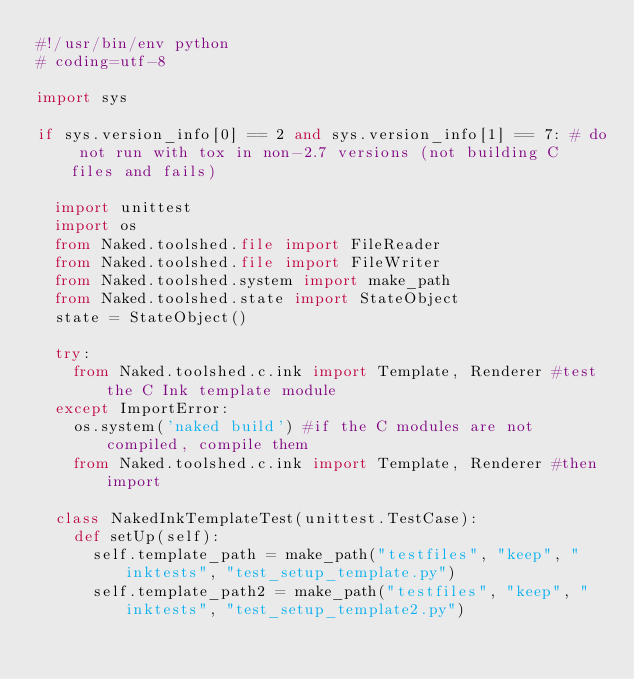<code> <loc_0><loc_0><loc_500><loc_500><_Python_>#!/usr/bin/env python
# coding=utf-8

import sys

if sys.version_info[0] == 2 and sys.version_info[1] == 7: # do not run with tox in non-2.7 versions (not building C files and fails)

	import unittest
	import os
	from Naked.toolshed.file import FileReader
	from Naked.toolshed.file import FileWriter
	from Naked.toolshed.system import make_path
	from Naked.toolshed.state import StateObject
	state = StateObject()

	try:
		from Naked.toolshed.c.ink import Template, Renderer #test the C Ink template module
	except ImportError:
		os.system('naked build') #if the C modules are not compiled, compile them
		from Naked.toolshed.c.ink import Template, Renderer #then import

	class NakedInkTemplateTest(unittest.TestCase):
		def setUp(self):
			self.template_path = make_path("testfiles", "keep", "inktests", "test_setup_template.py")
			self.template_path2 = make_path("testfiles", "keep", "inktests", "test_setup_template2.py")</code> 